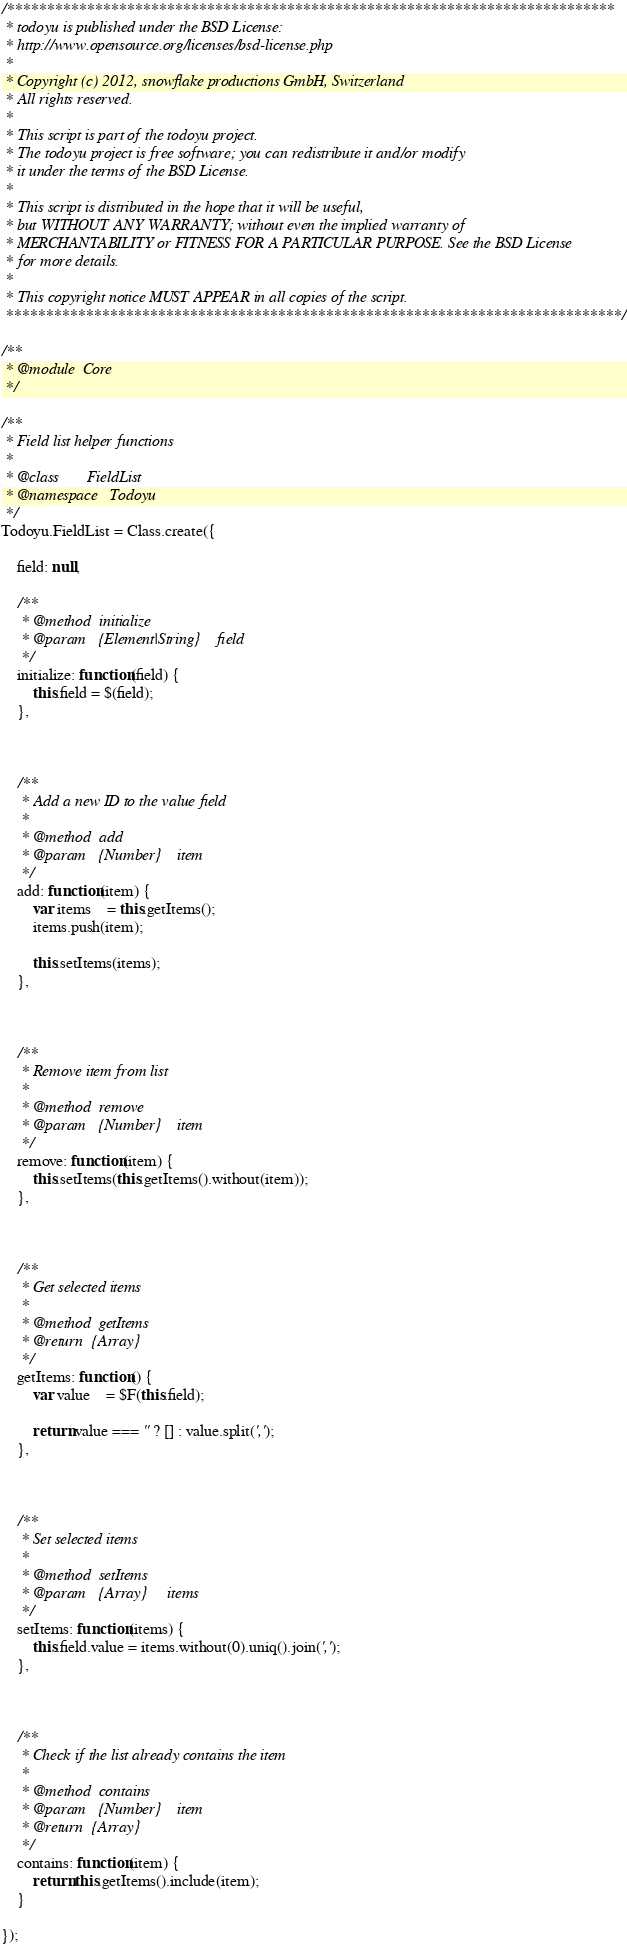<code> <loc_0><loc_0><loc_500><loc_500><_JavaScript_>/****************************************************************************
 * todoyu is published under the BSD License:
 * http://www.opensource.org/licenses/bsd-license.php
 *
 * Copyright (c) 2012, snowflake productions GmbH, Switzerland
 * All rights reserved.
 *
 * This script is part of the todoyu project.
 * The todoyu project is free software; you can redistribute it and/or modify
 * it under the terms of the BSD License.
 *
 * This script is distributed in the hope that it will be useful,
 * but WITHOUT ANY WARRANTY; without even the implied warranty of
 * MERCHANTABILITY or FITNESS FOR A PARTICULAR PURPOSE. See the BSD License
 * for more details.
 *
 * This copyright notice MUST APPEAR in all copies of the script.
 *****************************************************************************/

/**
 * @module	Core
 */

/**
 * Field list helper functions
 *
 * @class		FieldList
 * @namespace	Todoyu
 */
Todoyu.FieldList = Class.create({

	field: null,

	/**
	 * @method	initialize
	 * @param	{Element|String}	field
	 */
	initialize: function(field) {
		this.field = $(field);
	},



	/**
	 * Add a new ID to the value field
	 *
	 * @method	add
	 * @param	{Number}	item
	 */
	add: function(item) {
		var items	= this.getItems();
		items.push(item);

		this.setItems(items);
	},



	/**
	 * Remove item from list
	 *
	 * @method	remove
	 * @param	{Number}	item
	 */
	remove: function(item) {
		this.setItems(this.getItems().without(item));
	},



	/**
	 * Get selected items
	 *
	 * @method	getItems
	 * @return	{Array}
	 */
	getItems: function() {
		var value	= $F(this.field);

		return value === '' ? [] : value.split(',');
	},



	/**
	 * Set selected items
	 *
	 * @method	setItems
	 * @param	{Array}		items
	 */
	setItems: function(items) {
		this.field.value = items.without(0).uniq().join(',');
	},



	/**
	 * Check if the list already contains the item
	 *
	 * @method	contains
	 * @param	{Number}	item
	 * @return	{Array}
	 */
	contains: function(item) {
		return this.getItems().include(item);
	}

});</code> 